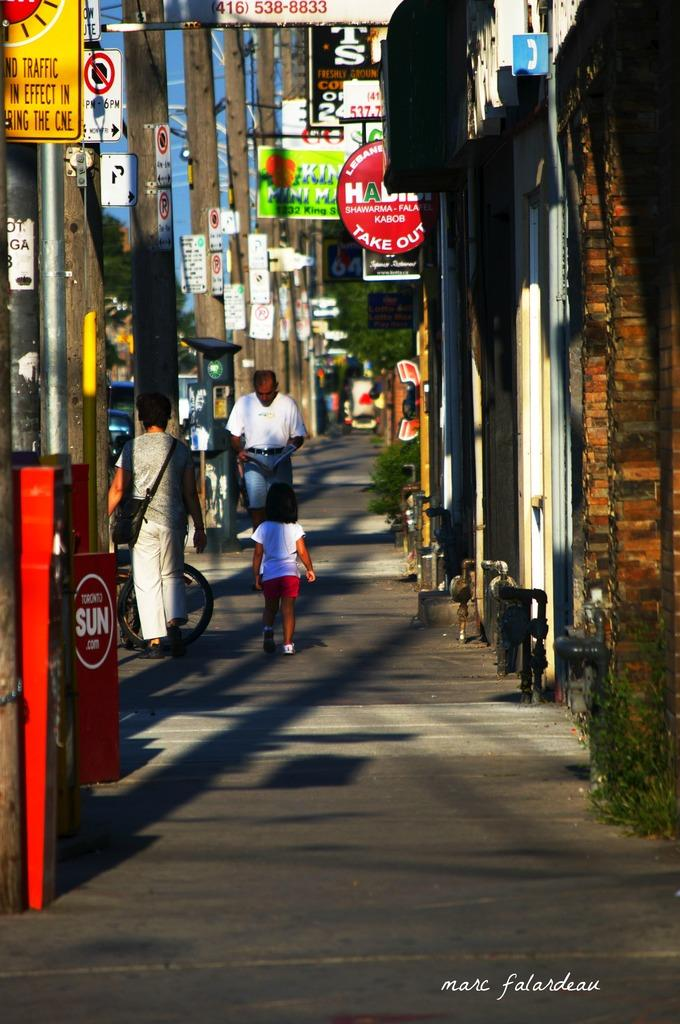<image>
Give a short and clear explanation of the subsequent image. Yellow Traffic In Effect sign in front of a building. 